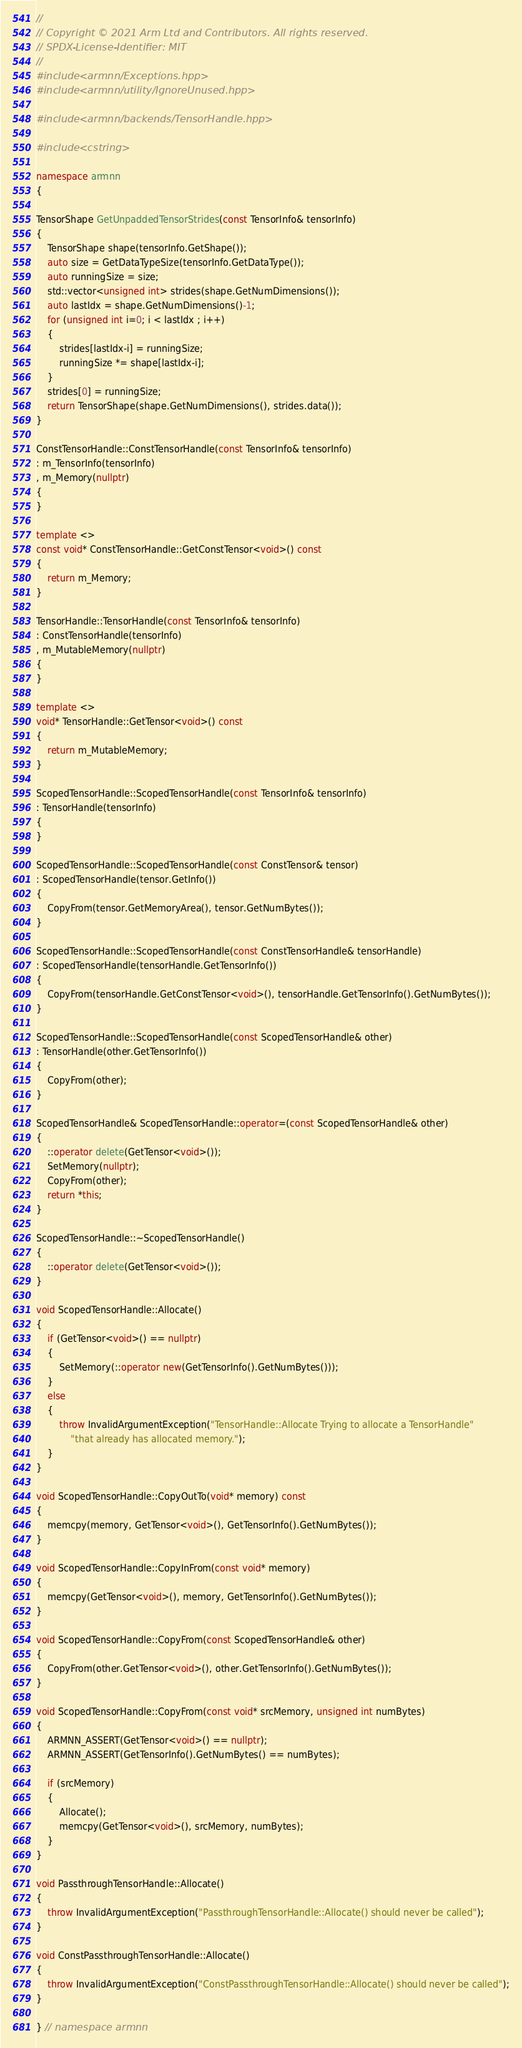Convert code to text. <code><loc_0><loc_0><loc_500><loc_500><_C++_>//
// Copyright © 2021 Arm Ltd and Contributors. All rights reserved.
// SPDX-License-Identifier: MIT
//
#include <armnn/Exceptions.hpp>
#include <armnn/utility/IgnoreUnused.hpp>

#include <armnn/backends/TensorHandle.hpp>

#include <cstring>

namespace armnn
{

TensorShape GetUnpaddedTensorStrides(const TensorInfo& tensorInfo)
{
    TensorShape shape(tensorInfo.GetShape());
    auto size = GetDataTypeSize(tensorInfo.GetDataType());
    auto runningSize = size;
    std::vector<unsigned int> strides(shape.GetNumDimensions());
    auto lastIdx = shape.GetNumDimensions()-1;
    for (unsigned int i=0; i < lastIdx ; i++)
    {
        strides[lastIdx-i] = runningSize;
        runningSize *= shape[lastIdx-i];
    }
    strides[0] = runningSize;
    return TensorShape(shape.GetNumDimensions(), strides.data());
}

ConstTensorHandle::ConstTensorHandle(const TensorInfo& tensorInfo)
: m_TensorInfo(tensorInfo)
, m_Memory(nullptr)
{
}

template <>
const void* ConstTensorHandle::GetConstTensor<void>() const
{
    return m_Memory;
}

TensorHandle::TensorHandle(const TensorInfo& tensorInfo)
: ConstTensorHandle(tensorInfo)
, m_MutableMemory(nullptr)
{
}

template <>
void* TensorHandle::GetTensor<void>() const
{
    return m_MutableMemory;
}

ScopedTensorHandle::ScopedTensorHandle(const TensorInfo& tensorInfo)
: TensorHandle(tensorInfo)
{
}

ScopedTensorHandle::ScopedTensorHandle(const ConstTensor& tensor)
: ScopedTensorHandle(tensor.GetInfo())
{
    CopyFrom(tensor.GetMemoryArea(), tensor.GetNumBytes());
}

ScopedTensorHandle::ScopedTensorHandle(const ConstTensorHandle& tensorHandle)
: ScopedTensorHandle(tensorHandle.GetTensorInfo())
{
    CopyFrom(tensorHandle.GetConstTensor<void>(), tensorHandle.GetTensorInfo().GetNumBytes());
}

ScopedTensorHandle::ScopedTensorHandle(const ScopedTensorHandle& other)
: TensorHandle(other.GetTensorInfo())
{
    CopyFrom(other);
}

ScopedTensorHandle& ScopedTensorHandle::operator=(const ScopedTensorHandle& other)
{
    ::operator delete(GetTensor<void>());
    SetMemory(nullptr);
    CopyFrom(other);
    return *this;
}

ScopedTensorHandle::~ScopedTensorHandle()
{
    ::operator delete(GetTensor<void>());
}

void ScopedTensorHandle::Allocate()
{
    if (GetTensor<void>() == nullptr)
    {
        SetMemory(::operator new(GetTensorInfo().GetNumBytes()));
    }
    else
    {
        throw InvalidArgumentException("TensorHandle::Allocate Trying to allocate a TensorHandle"
            "that already has allocated memory.");
    }
}

void ScopedTensorHandle::CopyOutTo(void* memory) const
{
    memcpy(memory, GetTensor<void>(), GetTensorInfo().GetNumBytes());
}

void ScopedTensorHandle::CopyInFrom(const void* memory)
{
    memcpy(GetTensor<void>(), memory, GetTensorInfo().GetNumBytes());
}

void ScopedTensorHandle::CopyFrom(const ScopedTensorHandle& other)
{
    CopyFrom(other.GetTensor<void>(), other.GetTensorInfo().GetNumBytes());
}

void ScopedTensorHandle::CopyFrom(const void* srcMemory, unsigned int numBytes)
{
    ARMNN_ASSERT(GetTensor<void>() == nullptr);
    ARMNN_ASSERT(GetTensorInfo().GetNumBytes() == numBytes);

    if (srcMemory)
    {
        Allocate();
        memcpy(GetTensor<void>(), srcMemory, numBytes);
    }
}

void PassthroughTensorHandle::Allocate()
{
    throw InvalidArgumentException("PassthroughTensorHandle::Allocate() should never be called");
}

void ConstPassthroughTensorHandle::Allocate()
{
    throw InvalidArgumentException("ConstPassthroughTensorHandle::Allocate() should never be called");
}

} // namespace armnn
</code> 